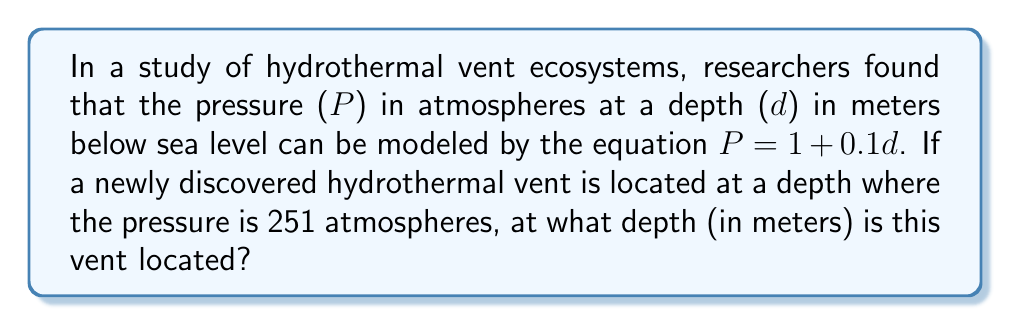Provide a solution to this math problem. Let's approach this step-by-step:

1) We are given the equation relating pressure (P) to depth (d):
   $P = 1 + 0.1d$

2) We know that at the location of the hydrothermal vent, the pressure is 251 atmospheres. Let's substitute this into our equation:
   $251 = 1 + 0.1d$

3) To solve for d, we first subtract 1 from both sides:
   $250 = 0.1d$

4) Now, we divide both sides by 0.1:
   $\frac{250}{0.1} = d$

5) Simplify:
   $2500 = d$

Therefore, the hydrothermal vent is located at a depth of 2500 meters below sea level.
Answer: 2500 meters 